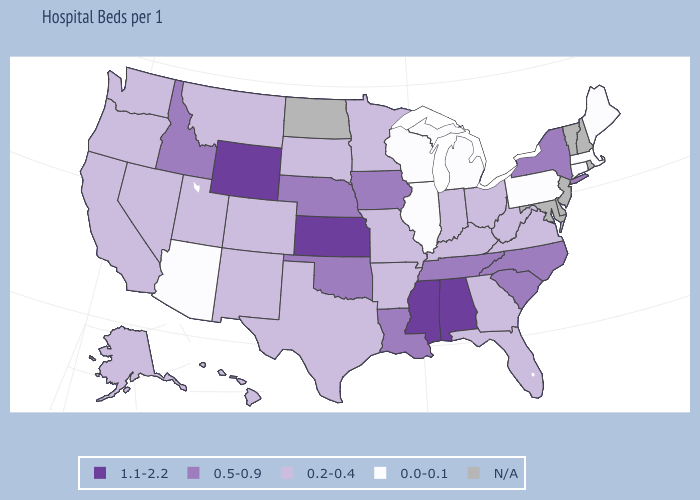Name the states that have a value in the range 0.0-0.1?
Concise answer only. Arizona, Connecticut, Illinois, Maine, Massachusetts, Michigan, Pennsylvania, Wisconsin. What is the value of Illinois?
Be succinct. 0.0-0.1. What is the value of Ohio?
Keep it brief. 0.2-0.4. Which states have the lowest value in the West?
Write a very short answer. Arizona. Name the states that have a value in the range 1.1-2.2?
Be succinct. Alabama, Kansas, Mississippi, Wyoming. Which states hav the highest value in the West?
Give a very brief answer. Wyoming. Name the states that have a value in the range 1.1-2.2?
Give a very brief answer. Alabama, Kansas, Mississippi, Wyoming. What is the value of Minnesota?
Be succinct. 0.2-0.4. Among the states that border Connecticut , does Massachusetts have the lowest value?
Answer briefly. Yes. Name the states that have a value in the range N/A?
Keep it brief. Delaware, Maryland, New Hampshire, New Jersey, North Dakota, Rhode Island, Vermont. Does Pennsylvania have the lowest value in the Northeast?
Write a very short answer. Yes. Among the states that border Washington , which have the highest value?
Give a very brief answer. Idaho. What is the highest value in the USA?
Short answer required. 1.1-2.2. 